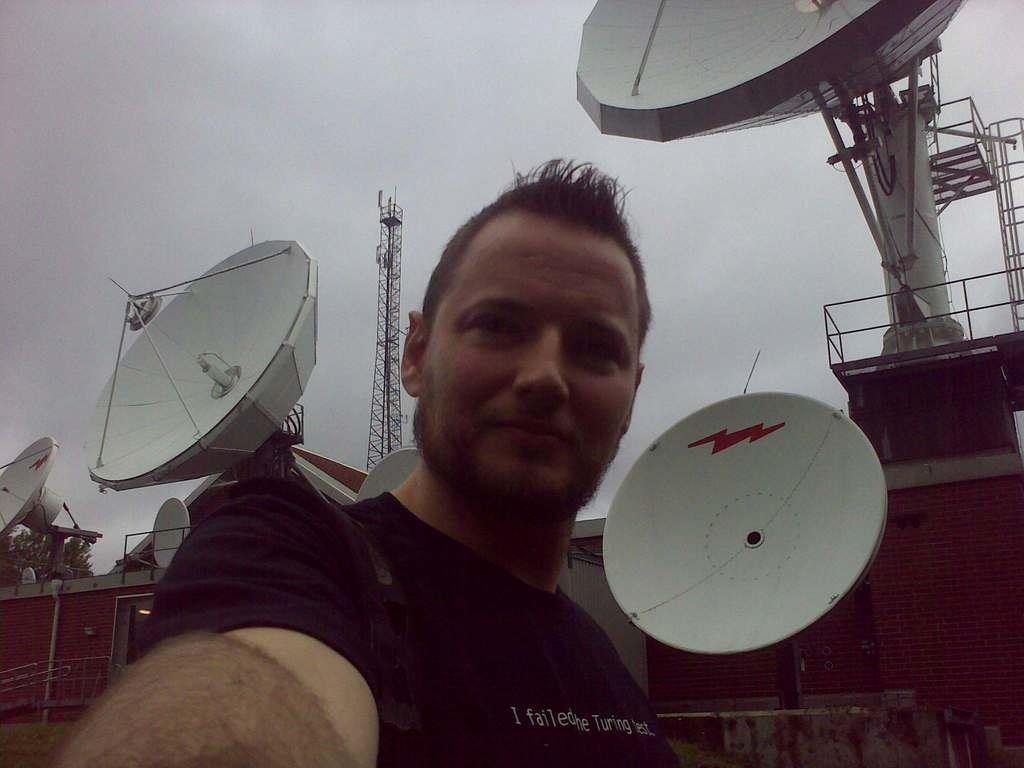Please provide a concise description of this image. In this image we can see a person. In the background there are antennas, buildings, towers, trees and sky. 